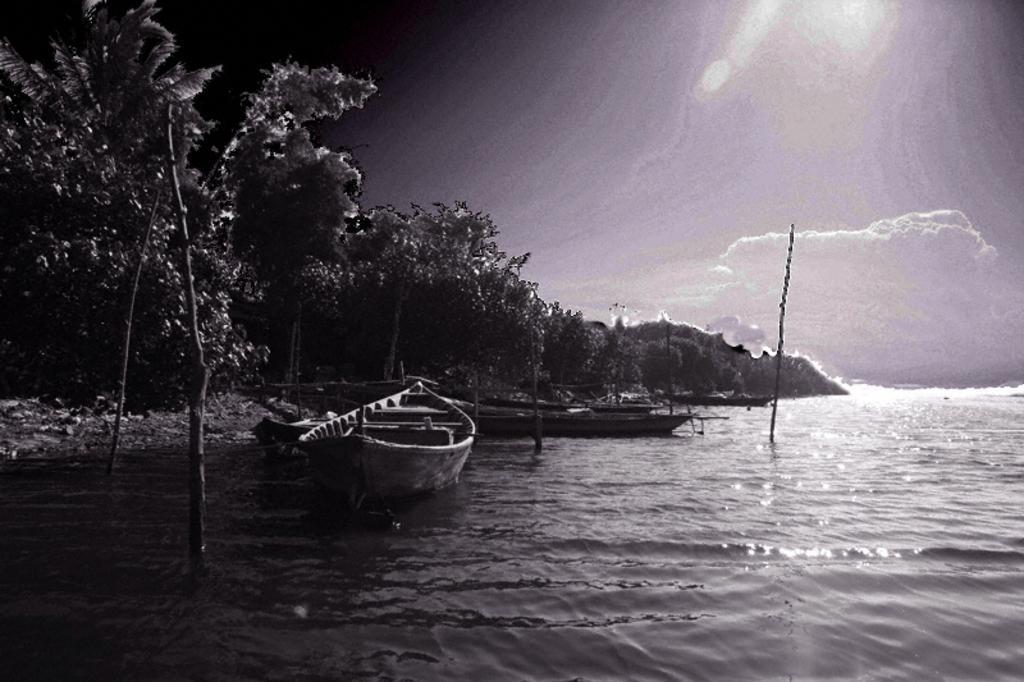Could you give a brief overview of what you see in this image? In this picture there are few boats on the water and there are few trees in the left corner. 